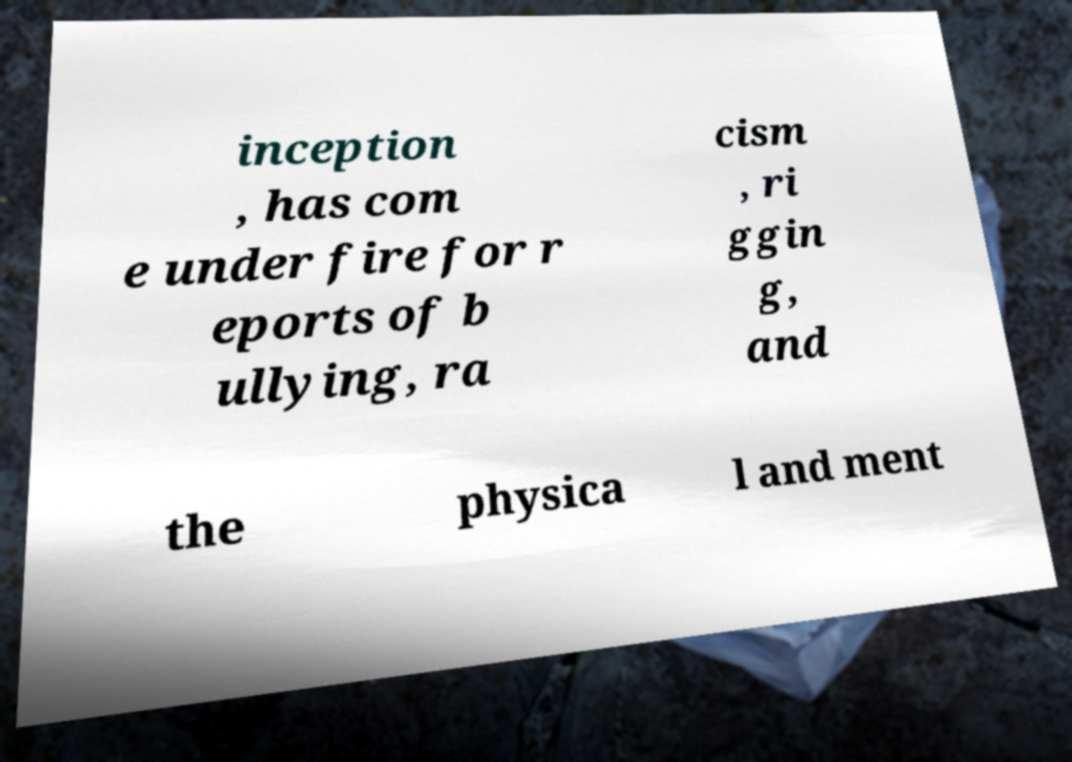For documentation purposes, I need the text within this image transcribed. Could you provide that? inception , has com e under fire for r eports of b ullying, ra cism , ri ggin g, and the physica l and ment 